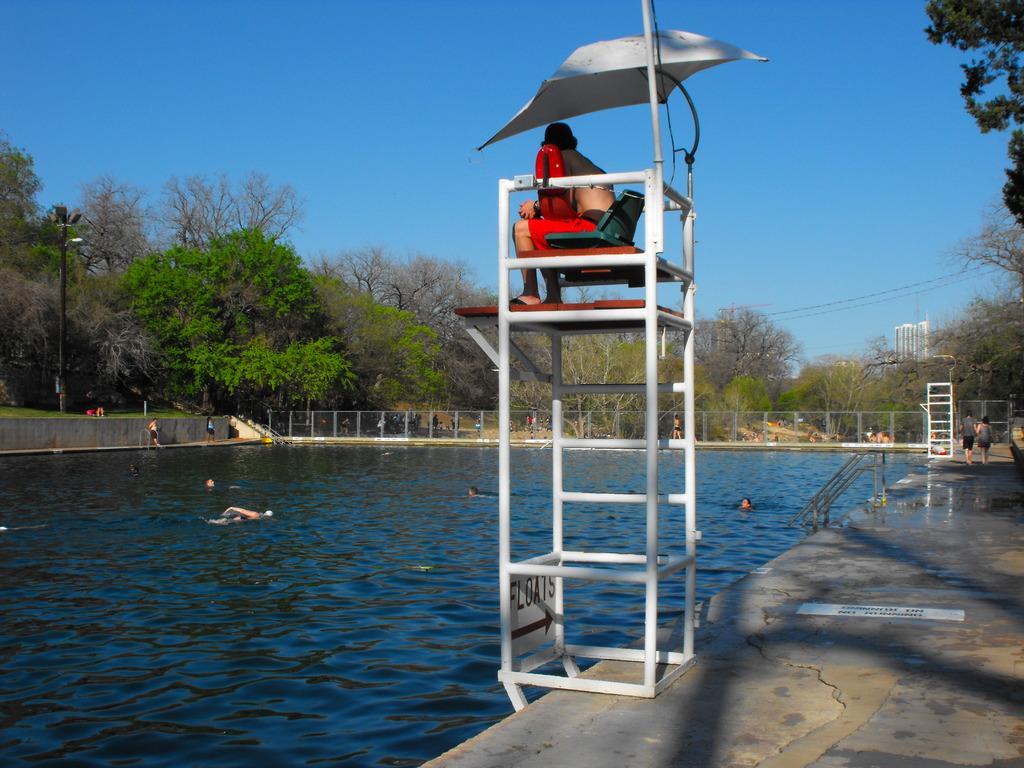In one or two sentences, can you explain what this image depicts? In this image we can see a person sitting on a chair in the top and in the background of the image there are some persons swimming in the pool, there is fencing, there are some trees and top of the image there is clear sky. 